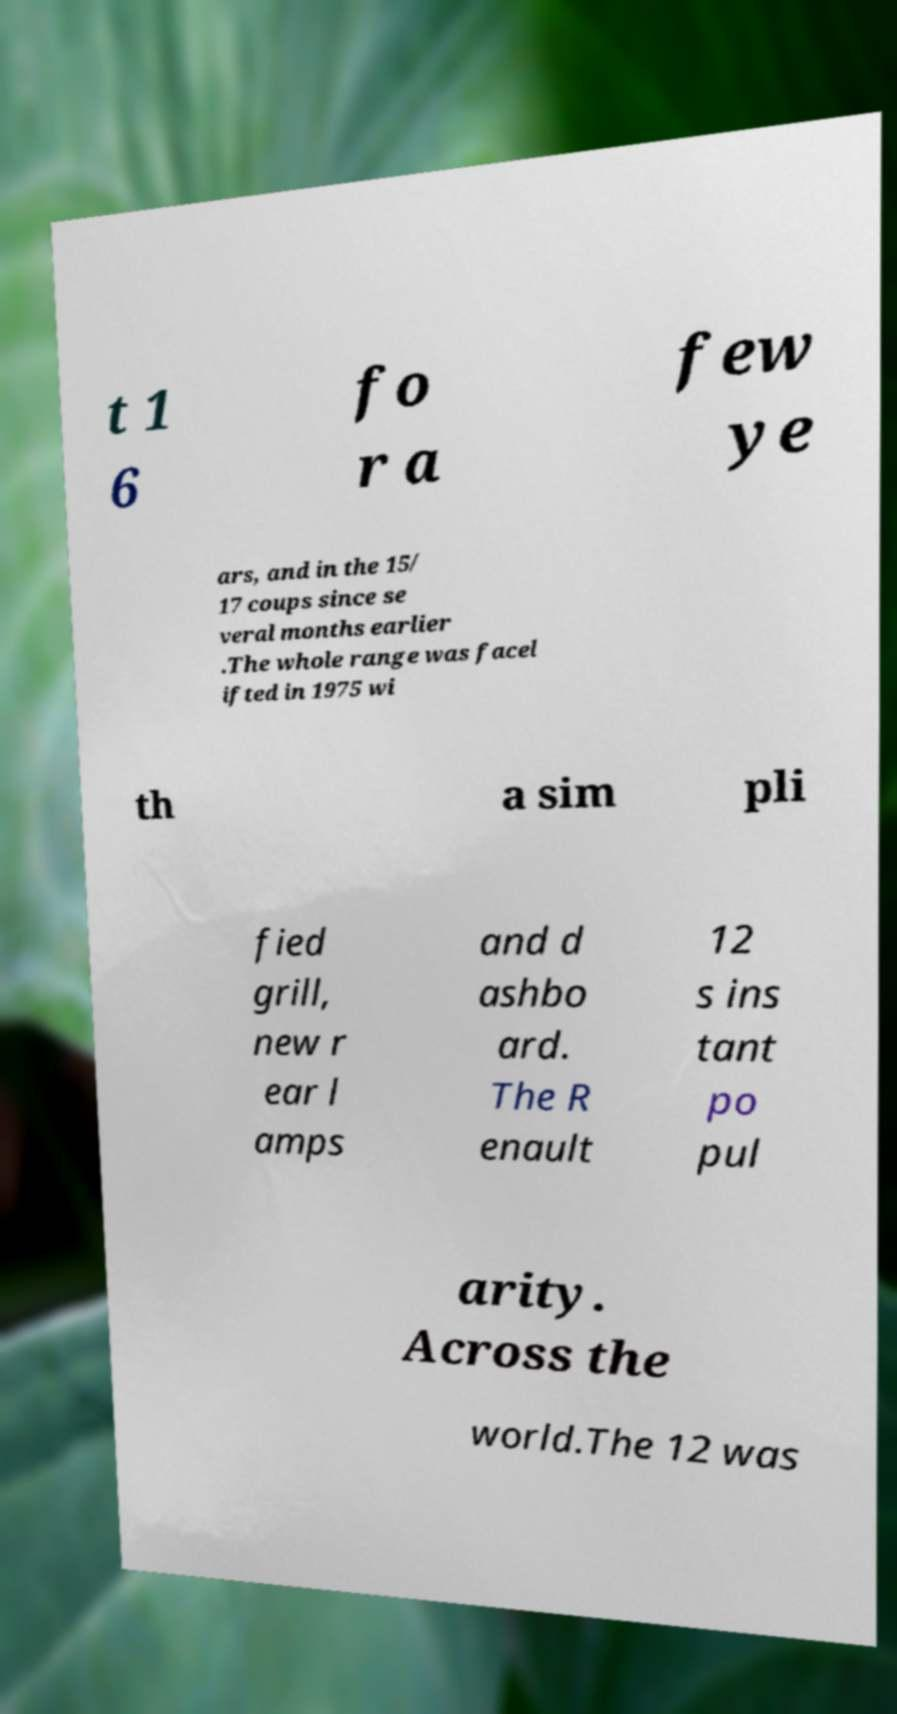For documentation purposes, I need the text within this image transcribed. Could you provide that? t 1 6 fo r a few ye ars, and in the 15/ 17 coups since se veral months earlier .The whole range was facel ifted in 1975 wi th a sim pli fied grill, new r ear l amps and d ashbo ard. The R enault 12 s ins tant po pul arity. Across the world.The 12 was 